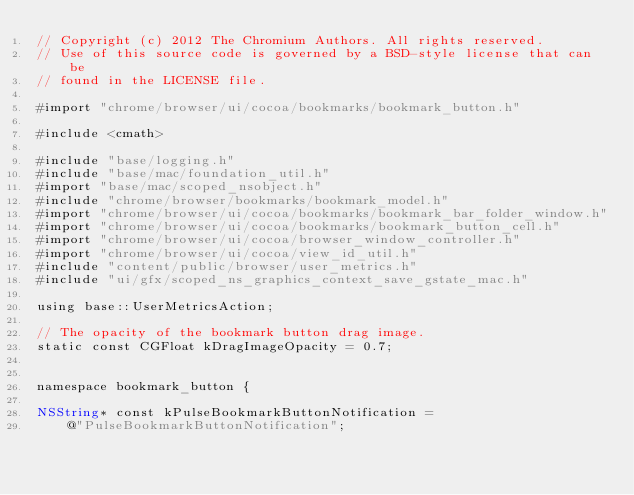<code> <loc_0><loc_0><loc_500><loc_500><_ObjectiveC_>// Copyright (c) 2012 The Chromium Authors. All rights reserved.
// Use of this source code is governed by a BSD-style license that can be
// found in the LICENSE file.

#import "chrome/browser/ui/cocoa/bookmarks/bookmark_button.h"

#include <cmath>

#include "base/logging.h"
#include "base/mac/foundation_util.h"
#import "base/mac/scoped_nsobject.h"
#include "chrome/browser/bookmarks/bookmark_model.h"
#import "chrome/browser/ui/cocoa/bookmarks/bookmark_bar_folder_window.h"
#import "chrome/browser/ui/cocoa/bookmarks/bookmark_button_cell.h"
#import "chrome/browser/ui/cocoa/browser_window_controller.h"
#import "chrome/browser/ui/cocoa/view_id_util.h"
#include "content/public/browser/user_metrics.h"
#include "ui/gfx/scoped_ns_graphics_context_save_gstate_mac.h"

using base::UserMetricsAction;

// The opacity of the bookmark button drag image.
static const CGFloat kDragImageOpacity = 0.7;


namespace bookmark_button {

NSString* const kPulseBookmarkButtonNotification =
    @"PulseBookmarkButtonNotification";</code> 